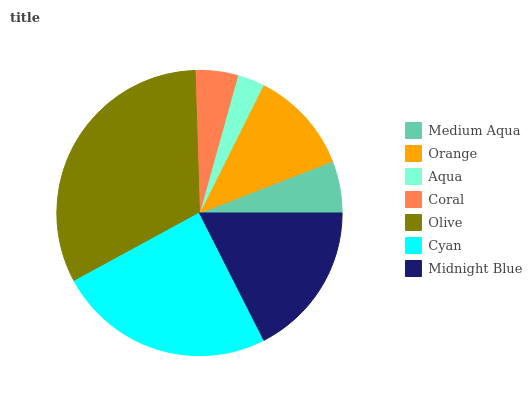Is Aqua the minimum?
Answer yes or no. Yes. Is Olive the maximum?
Answer yes or no. Yes. Is Orange the minimum?
Answer yes or no. No. Is Orange the maximum?
Answer yes or no. No. Is Orange greater than Medium Aqua?
Answer yes or no. Yes. Is Medium Aqua less than Orange?
Answer yes or no. Yes. Is Medium Aqua greater than Orange?
Answer yes or no. No. Is Orange less than Medium Aqua?
Answer yes or no. No. Is Orange the high median?
Answer yes or no. Yes. Is Orange the low median?
Answer yes or no. Yes. Is Coral the high median?
Answer yes or no. No. Is Medium Aqua the low median?
Answer yes or no. No. 